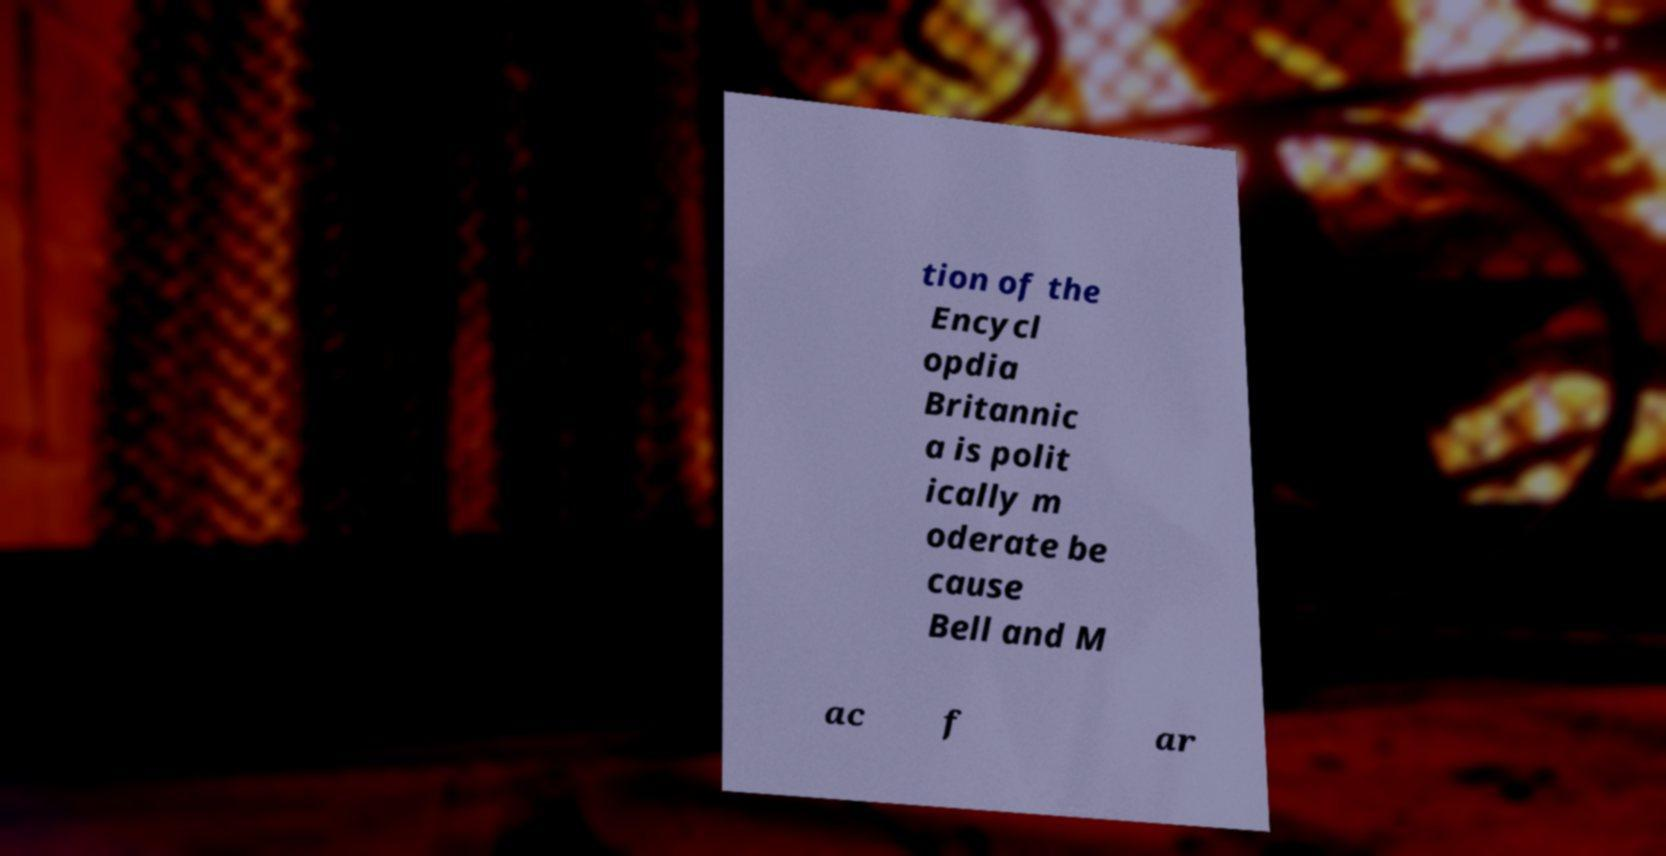For documentation purposes, I need the text within this image transcribed. Could you provide that? tion of the Encycl opdia Britannic a is polit ically m oderate be cause Bell and M ac f ar 